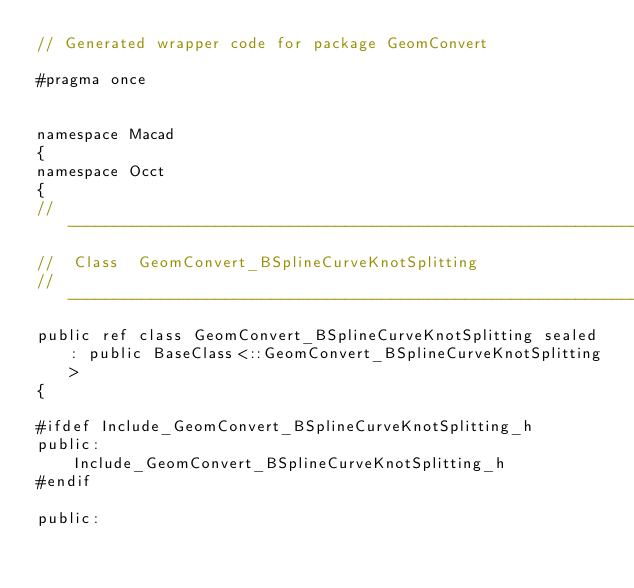<code> <loc_0><loc_0><loc_500><loc_500><_C_>// Generated wrapper code for package GeomConvert

#pragma once


namespace Macad
{
namespace Occt
{
//---------------------------------------------------------------------
//  Class  GeomConvert_BSplineCurveKnotSplitting
//---------------------------------------------------------------------
public ref class GeomConvert_BSplineCurveKnotSplitting sealed : public BaseClass<::GeomConvert_BSplineCurveKnotSplitting>
{

#ifdef Include_GeomConvert_BSplineCurveKnotSplitting_h
public:
	Include_GeomConvert_BSplineCurveKnotSplitting_h
#endif

public:</code> 